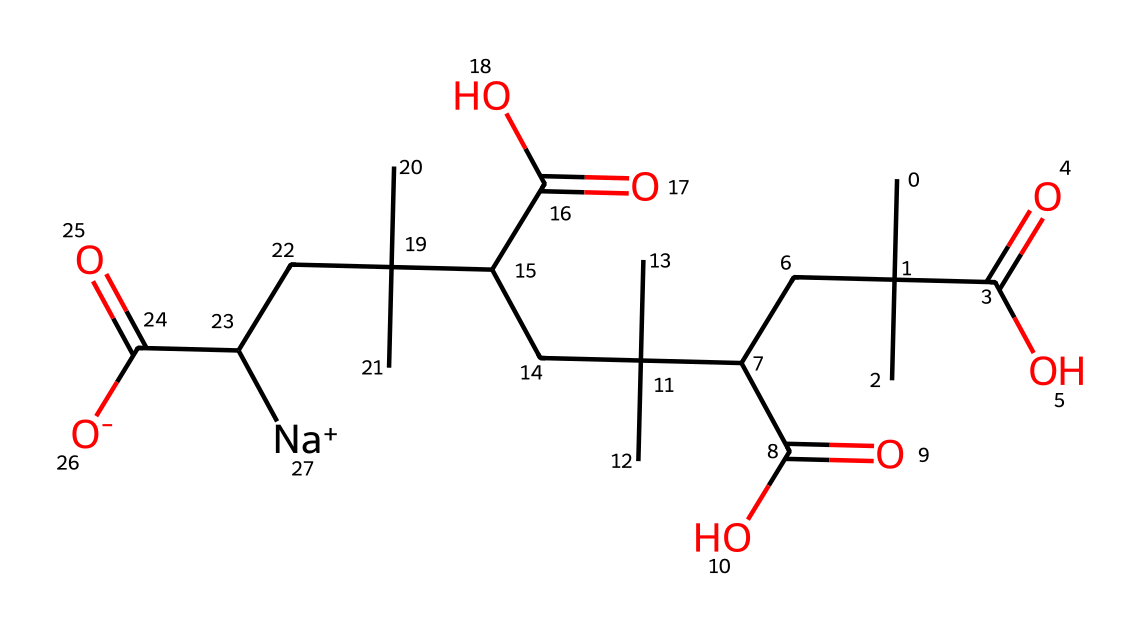What is the molecular formula of this compound? The SMILES representation provides a clear indication of the atoms present in the molecule. By interpreting the SMILES, we find carbon (C), hydrogen (H), oxygen (O), and sodium (Na) atoms. Counting the instances of each symbol gives the molecular formula. In this case, we have 24 carbons, 42 hydrogens, 6 oxygens, and 1 sodium.
Answer: C24H42O6Na How many different types of functional groups are present in this molecule? The SMILES representation indicates there are carboxyl (-COOH) groups, as evidenced by the presence of carbonyl (C=O) directly bonded to a hydroxyl group (O-H). The structure shows multiple carboxyl groups throughout, which can be counted. There are three unique locations suggesting three functional groups, mainly carboxylic acids.
Answer: 3 What role do the sodium ions play in this polymer? Sodium ions are typically associated with enhancing solubility or stability in a solution, especially in polymers aimed at absorption. In super-absorbent polymers, the sodium ion can help to neutralize the negative charge on the carboxylate groups, facilitating ion exchange processes and increasing the polymer's effectiveness in absorbing moisture.
Answer: enhance solubility What overall property does this polymer provide for hygiene products? Super-absorbent polymers are designed to absorb and retain large quantities of liquid relative to their own mass. The presence of multiple carboxylic acid groups lends to this capacity, allowing the polymer to swell upon exposure to fluids and provide an effective barrier in hygiene products during disaster relief.
Answer: absorbency What type of polymer structure is suggested by the SMILES notation? The SMILES notation indicates a branched structure due to the presence of multiple carbon chains. The connectivity pattern allows for a network formation, which is common in super-absorbent polymers. This kind of structure is known for maintaining flexibility and a high surface area for absorption.
Answer: branched structure 